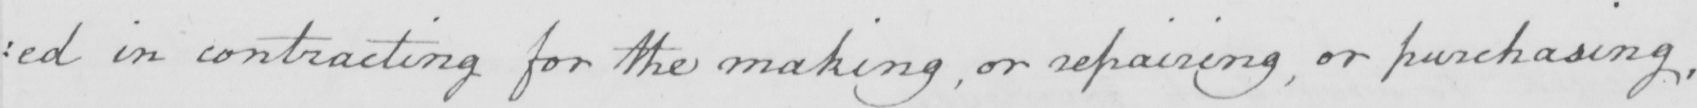Transcribe the text shown in this historical manuscript line. : ed in contracting for the making , or repairing , or purchasing , 